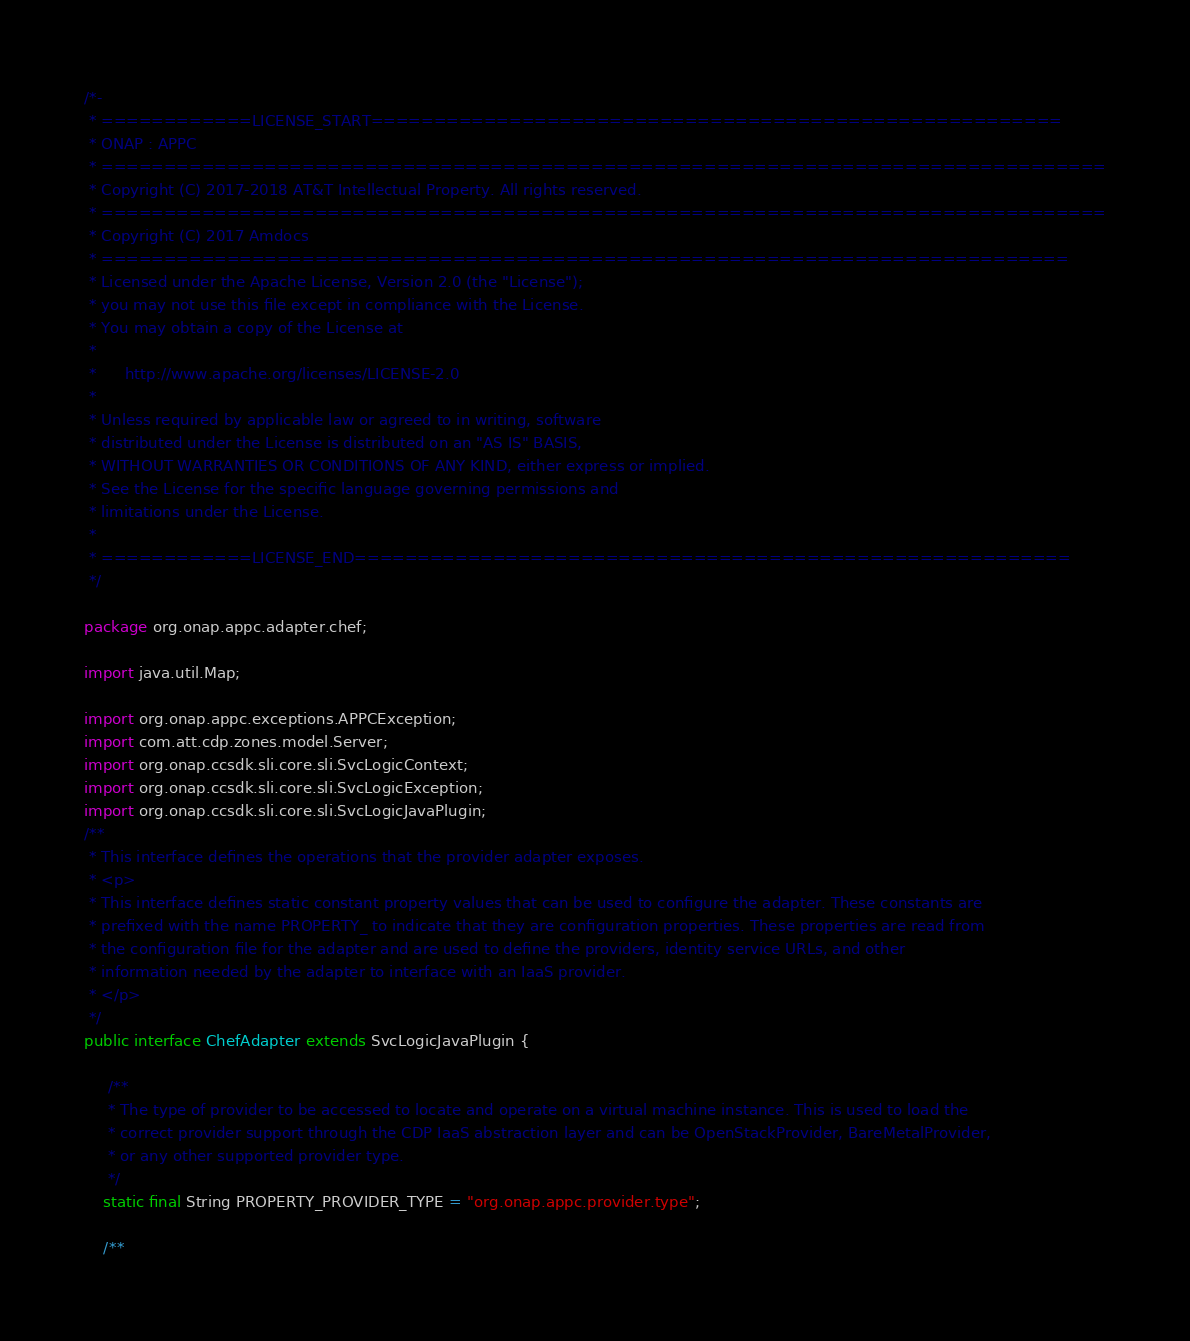Convert code to text. <code><loc_0><loc_0><loc_500><loc_500><_Java_>/*-
 * ============LICENSE_START=======================================================
 * ONAP : APPC
 * ================================================================================
 * Copyright (C) 2017-2018 AT&T Intellectual Property. All rights reserved.
 * ================================================================================
 * Copyright (C) 2017 Amdocs
 * =============================================================================
 * Licensed under the Apache License, Version 2.0 (the "License");
 * you may not use this file except in compliance with the License.
 * You may obtain a copy of the License at
 * 
 *      http://www.apache.org/licenses/LICENSE-2.0
 * 
 * Unless required by applicable law or agreed to in writing, software
 * distributed under the License is distributed on an "AS IS" BASIS,
 * WITHOUT WARRANTIES OR CONDITIONS OF ANY KIND, either express or implied.
 * See the License for the specific language governing permissions and
 * limitations under the License.
 * 
 * ============LICENSE_END=========================================================
 */

package org.onap.appc.adapter.chef;

import java.util.Map;

import org.onap.appc.exceptions.APPCException;
import com.att.cdp.zones.model.Server;
import org.onap.ccsdk.sli.core.sli.SvcLogicContext;
import org.onap.ccsdk.sli.core.sli.SvcLogicException;
import org.onap.ccsdk.sli.core.sli.SvcLogicJavaPlugin;
/**
 * This interface defines the operations that the provider adapter exposes.
 * <p>
 * This interface defines static constant property values that can be used to configure the adapter. These constants are
 * prefixed with the name PROPERTY_ to indicate that they are configuration properties. These properties are read from
 * the configuration file for the adapter and are used to define the providers, identity service URLs, and other
 * information needed by the adapter to interface with an IaaS provider.
 * </p>
 */
public interface ChefAdapter extends SvcLogicJavaPlugin {

     /**
     * The type of provider to be accessed to locate and operate on a virtual machine instance. This is used to load the
     * correct provider support through the CDP IaaS abstraction layer and can be OpenStackProvider, BareMetalProvider,
     * or any other supported provider type.
     */
    static final String PROPERTY_PROVIDER_TYPE = "org.onap.appc.provider.type";

    /**</code> 